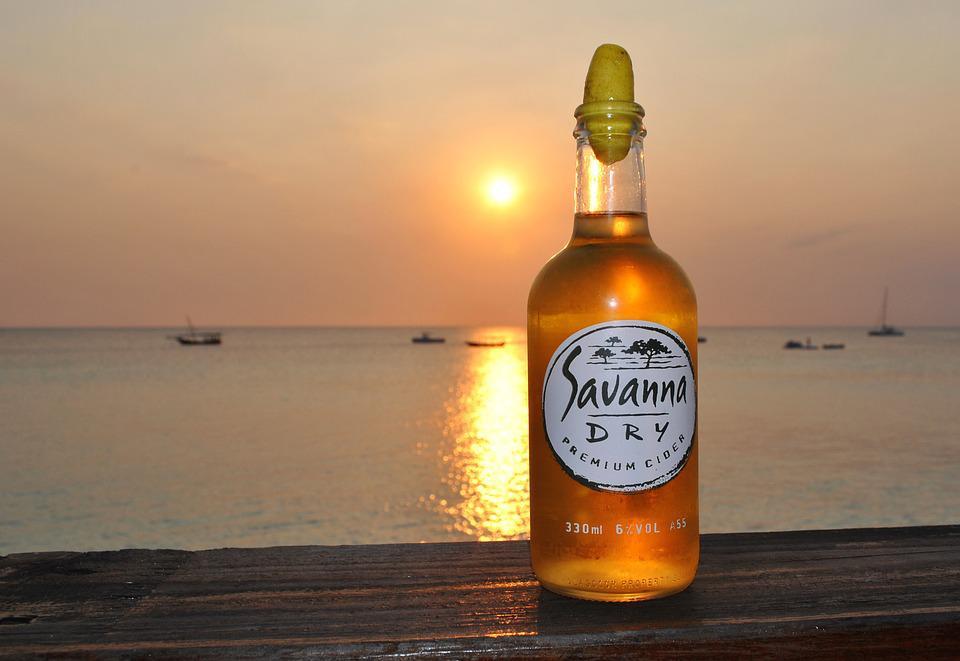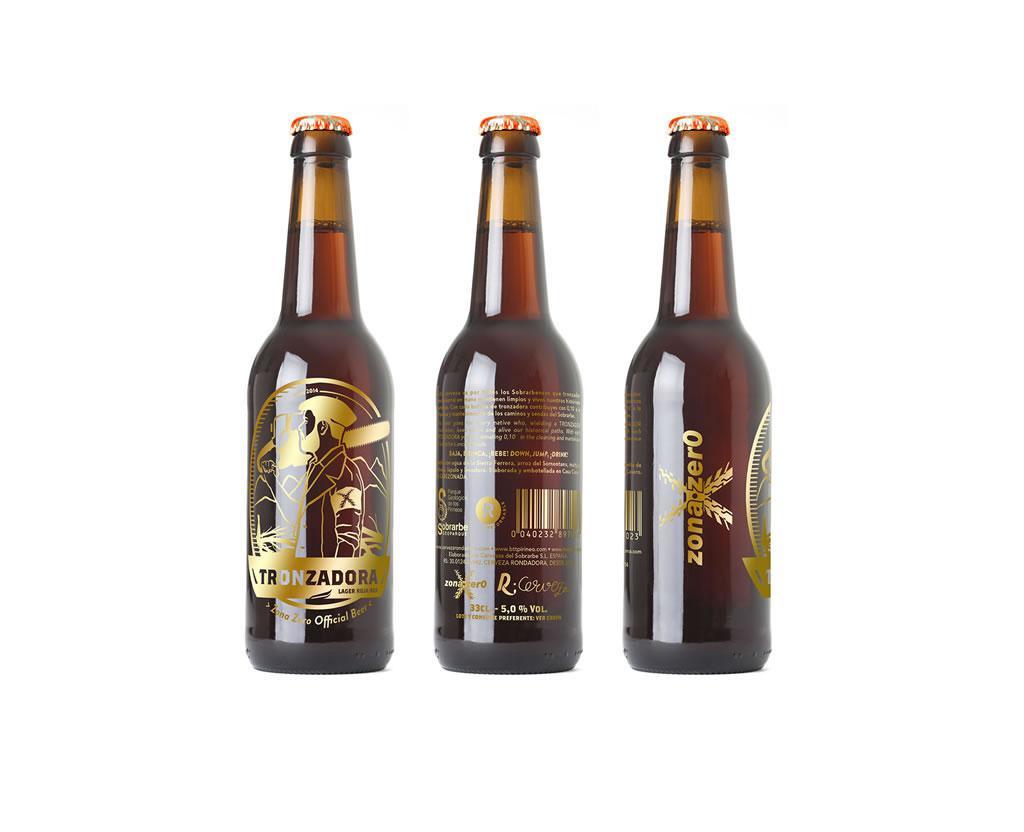The first image is the image on the left, the second image is the image on the right. Assess this claim about the two images: "At least one beer bottle is posed in front of a beach sunset, in one image.". Correct or not? Answer yes or no. Yes. The first image is the image on the left, the second image is the image on the right. Assess this claim about the two images: "All beverage bottles have labels around both the body and neck of the bottle.". Correct or not? Answer yes or no. No. 